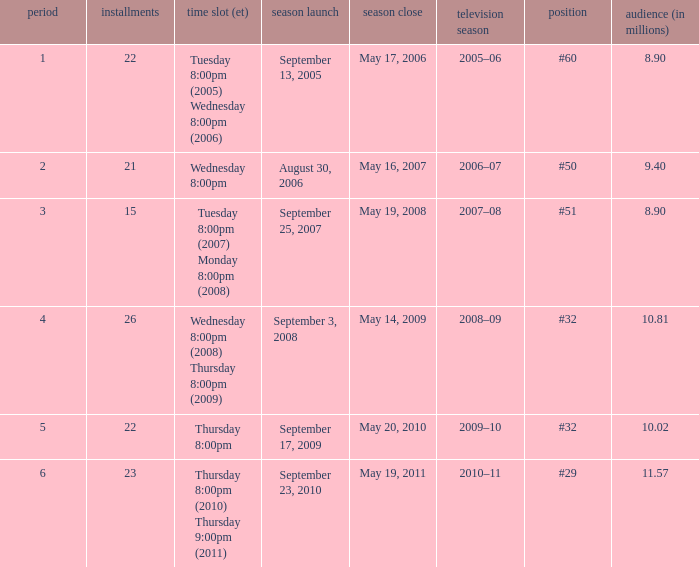When did the season finale reached an audience of 10.02 million viewers? May 20, 2010. 